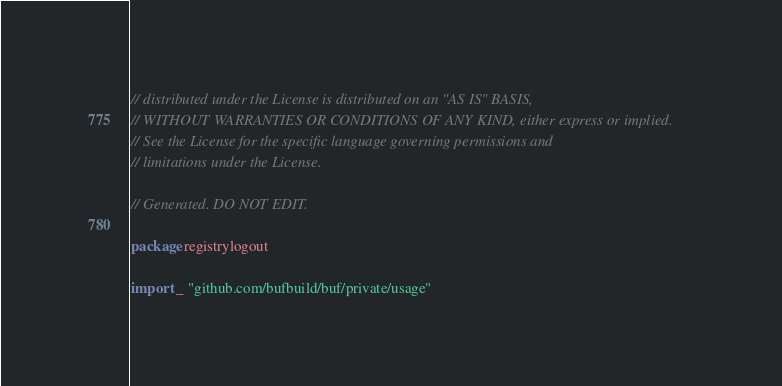Convert code to text. <code><loc_0><loc_0><loc_500><loc_500><_Go_>// distributed under the License is distributed on an "AS IS" BASIS,
// WITHOUT WARRANTIES OR CONDITIONS OF ANY KIND, either express or implied.
// See the License for the specific language governing permissions and
// limitations under the License.

// Generated. DO NOT EDIT.

package registrylogout

import _ "github.com/bufbuild/buf/private/usage"
</code> 